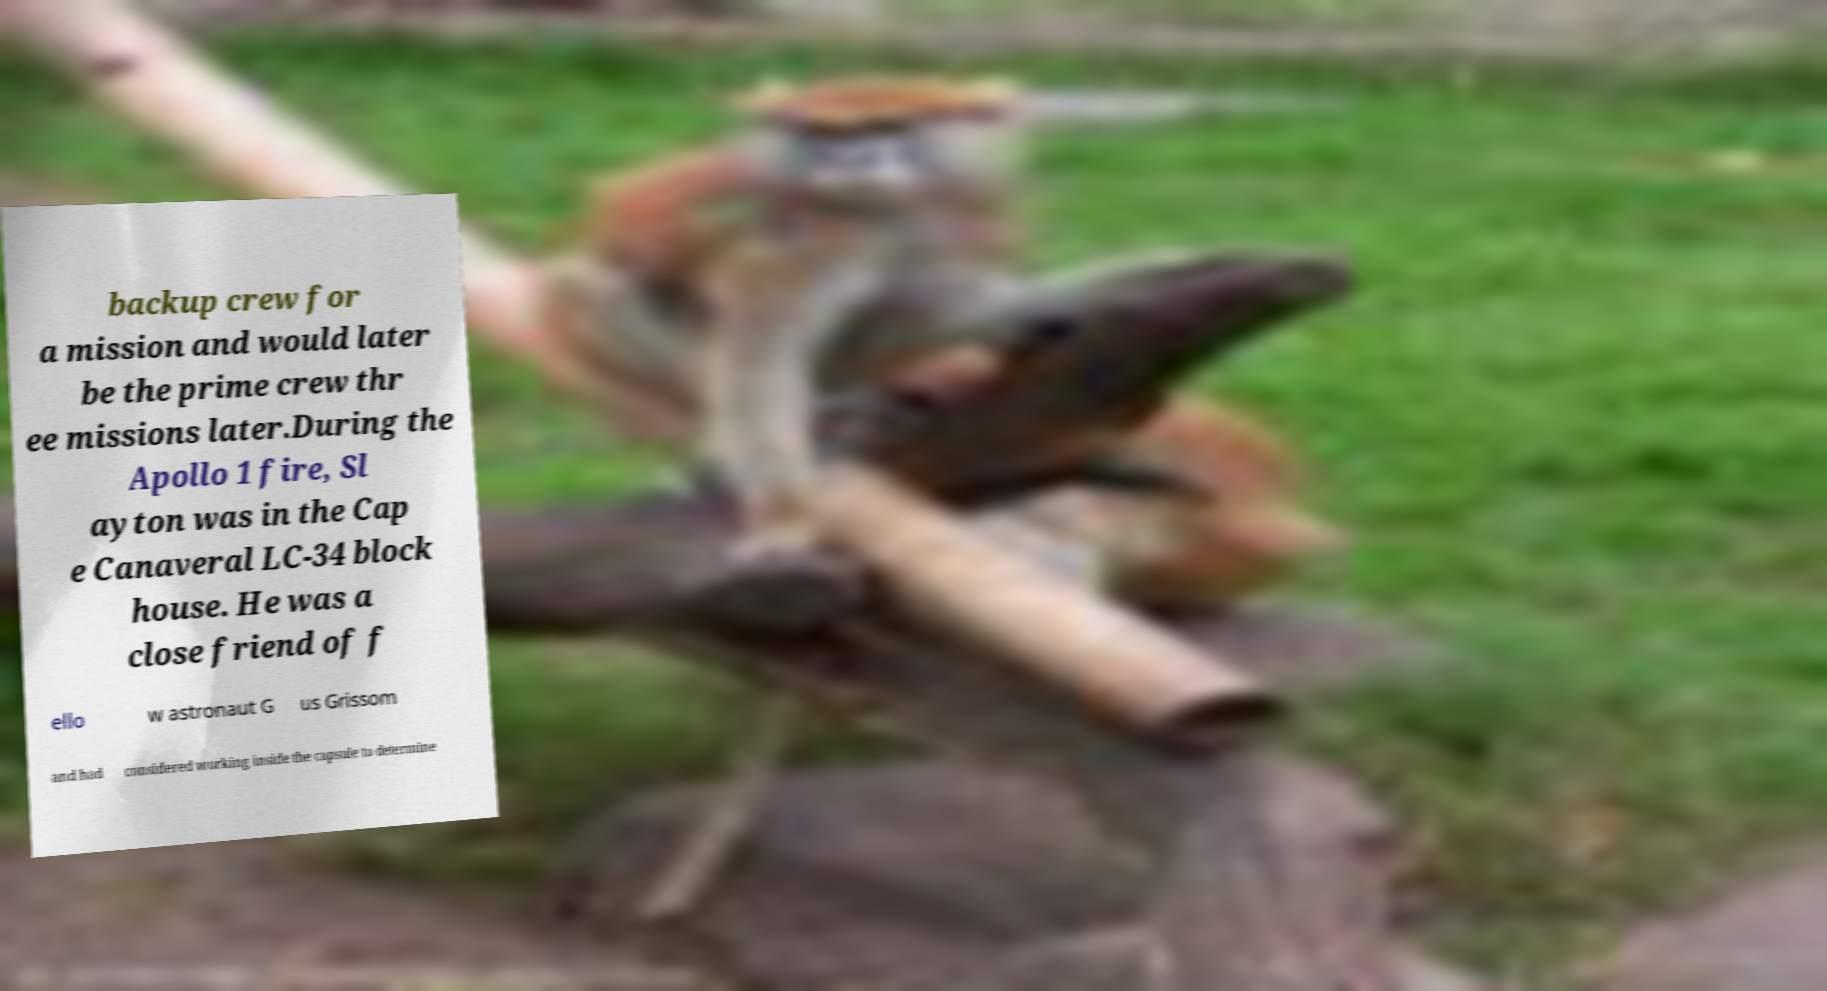I need the written content from this picture converted into text. Can you do that? backup crew for a mission and would later be the prime crew thr ee missions later.During the Apollo 1 fire, Sl ayton was in the Cap e Canaveral LC-34 block house. He was a close friend of f ello w astronaut G us Grissom and had considered working inside the capsule to determine 